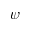Convert formula to latex. <formula><loc_0><loc_0><loc_500><loc_500>\psi</formula> 